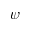Convert formula to latex. <formula><loc_0><loc_0><loc_500><loc_500>\psi</formula> 